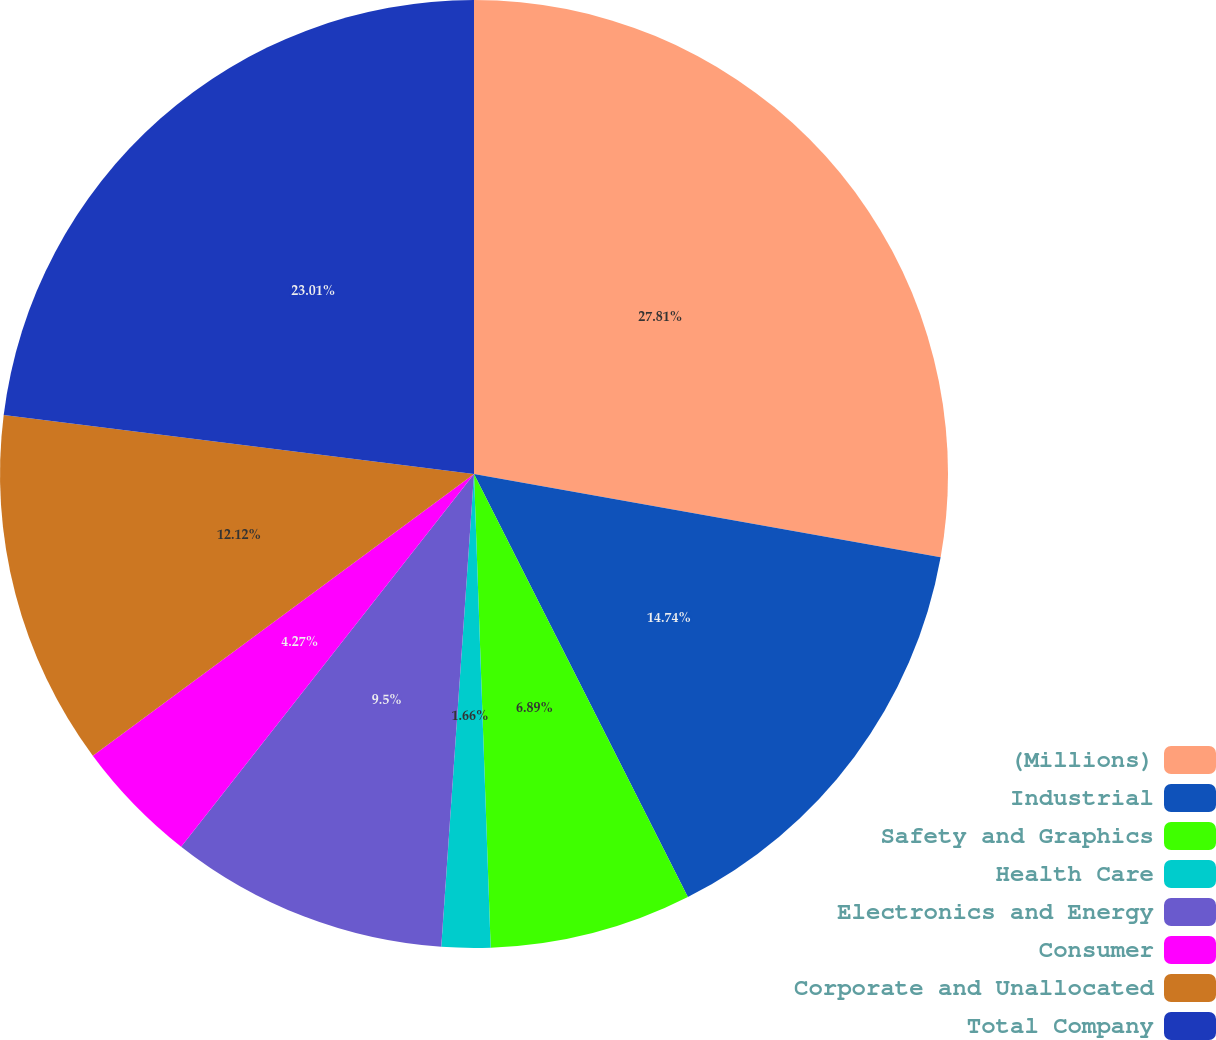Convert chart. <chart><loc_0><loc_0><loc_500><loc_500><pie_chart><fcel>(Millions)<fcel>Industrial<fcel>Safety and Graphics<fcel>Health Care<fcel>Electronics and Energy<fcel>Consumer<fcel>Corporate and Unallocated<fcel>Total Company<nl><fcel>27.81%<fcel>14.74%<fcel>6.89%<fcel>1.66%<fcel>9.5%<fcel>4.27%<fcel>12.12%<fcel>23.01%<nl></chart> 